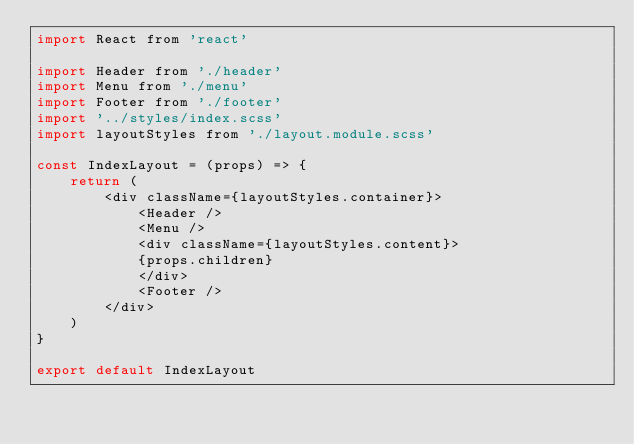Convert code to text. <code><loc_0><loc_0><loc_500><loc_500><_JavaScript_>import React from 'react'

import Header from './header'
import Menu from './menu'
import Footer from './footer'
import '../styles/index.scss'
import layoutStyles from './layout.module.scss'

const IndexLayout = (props) => {
    return (
        <div className={layoutStyles.container}>
            <Header />
            <Menu />
            <div className={layoutStyles.content}>
            {props.children} 
            </div>
            <Footer />  
        </div>
    )
}

export default IndexLayout</code> 